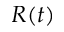Convert formula to latex. <formula><loc_0><loc_0><loc_500><loc_500>R ( t )</formula> 